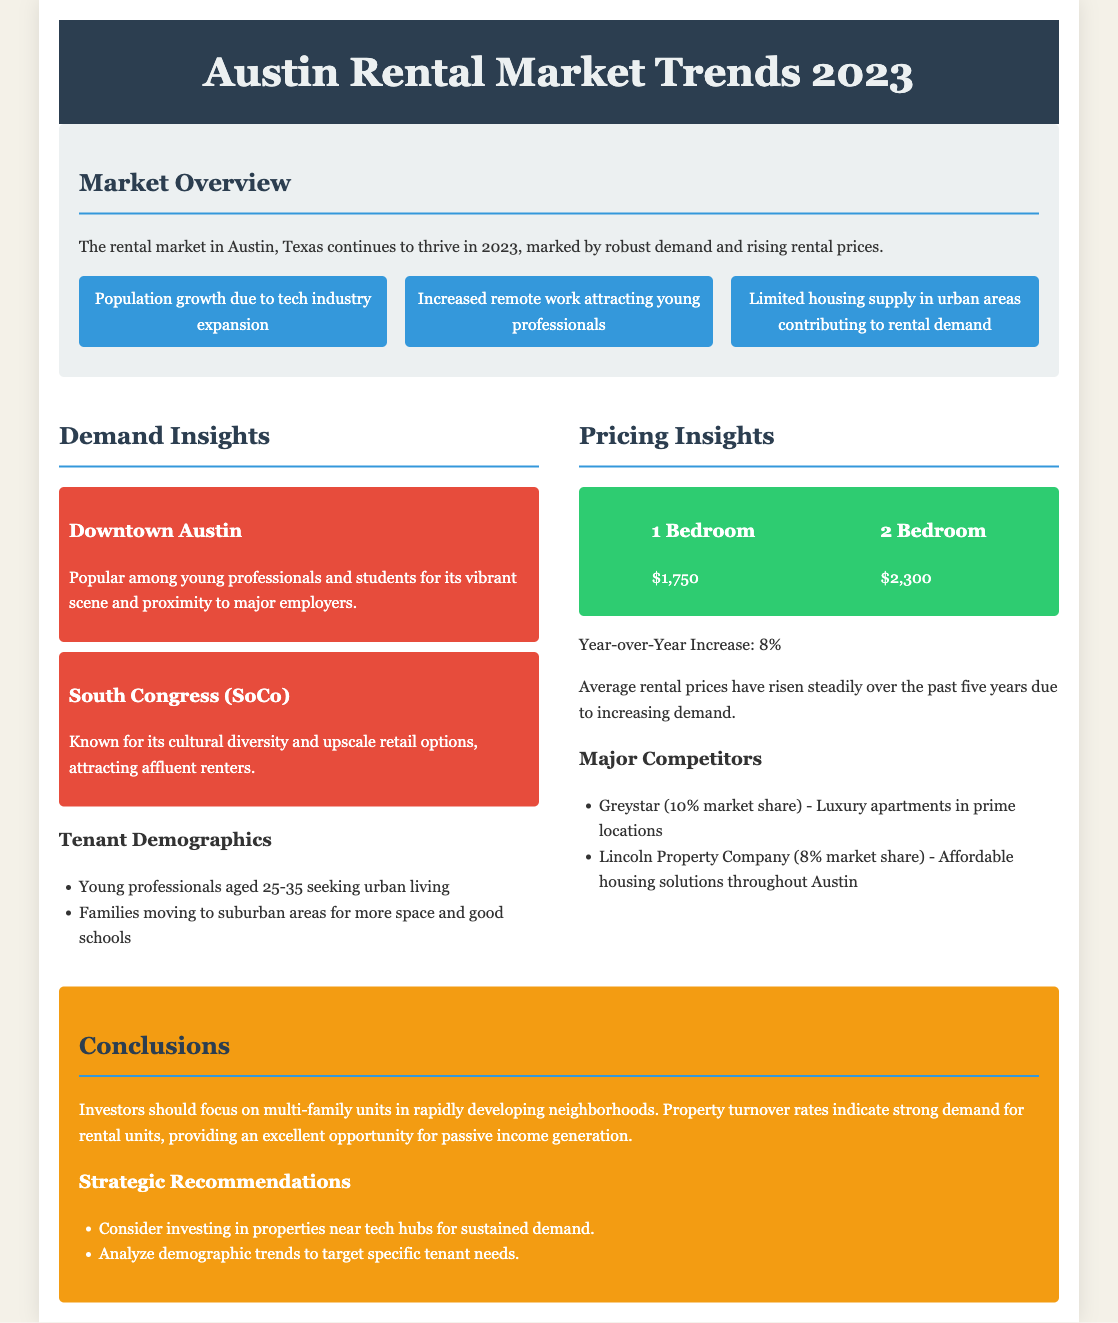What is the average rental price for a 1-bedroom apartment? The average rental price for a 1-bedroom apartment is directly stated in the document as $1,750.
Answer: $1,750 What is the year-over-year increase in rental prices? The document specifies that the year-over-year increase in rental prices is 8%.
Answer: 8% Which demographic is primarily attracted to Downtown Austin? The document lists that Downtown Austin is popular among young professionals and students due to its vibrant scene and proximity to major employers.
Answer: Young professionals What percentage of market share does Greystar hold? Greystar's market share percentage is explicitly noted in the document as 10%.
Answer: 10% What is a strategic recommendation for investors mentioned in the conclusions? The document states that one of the strategic recommendations for investors is to consider investing in properties near tech hubs for sustained demand.
Answer: Invest near tech hubs Which neighborhood is known for its cultural diversity? The document indicates that South Congress (SoCo) is known for its cultural diversity.
Answer: South Congress (SoCo) What has limited housing supply contributed to, according to the document? The document mentions that limited housing supply in urban areas has contributed to rental demand.
Answer: Rental demand What is a key factor affecting the Austin rental market in 2023? One of the key factors affecting the market is the population growth due to tech industry expansion.
Answer: Population growth due to tech industry expansion 